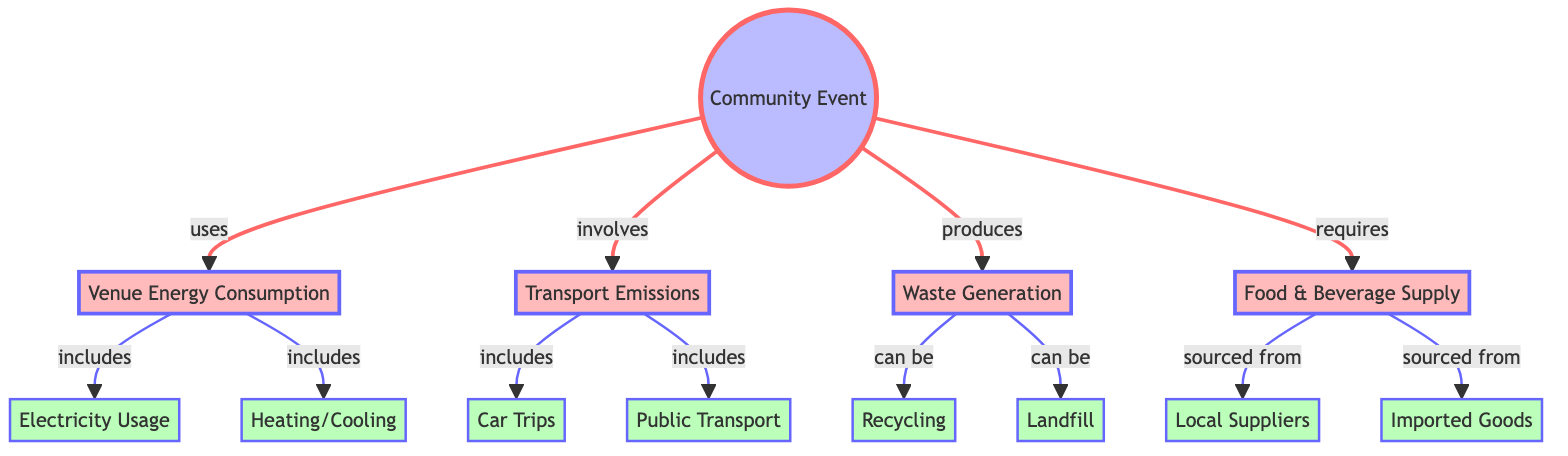What's the main subject of the diagram? The main subject of the diagram is located at the top node, labeled "Community Event," which indicates that the flowchart analyzes the carbon footprint associated with hosting such an event.
Answer: Community Event How many main sections are identified in the diagram? The main sections are divided into four categories: Venue Energy Consumption, Transport Emissions, Waste Generation, and Food & Beverage Supply. These can be identified as the immediate nodes directly connected to the main subject node.
Answer: 4 Which section includes electricity usage? The section that includes electricity usage is labeled as "Venue Energy Consumption," which directly connects to the node "Electricity Usage."
Answer: Venue Energy Consumption How many nodes are there in total in the diagram? The total node count includes the main node and all subsequent nodes from each section. There are 13 nodes total when counting them independently.
Answer: 13 What relation does "Food & Beverage Supply" have with "Local Suppliers"? The relationship is indicative of sourcing, where "Food & Beverage Supply" can be sourced from "Local Suppliers," showing a direct connection.
Answer: sourced from Which type of transport is included under Transport Emissions? The two types of transport emitted under this category are "Car Trips" and "Public Transport," both of which are detailed as sub-nodes under the "Transport Emissions" section.
Answer: Car Trips and Public Transport What is the effect of waste generation in the diagram? The waste generation can either result in "Recycling" or lead to "Landfill," indicating its impact on environmental management. These outcomes can be seen as consequences stemming from the waste generation node.
Answer: Recycling and Landfill How is energy consumption broken down in the diagram? Energy consumption is broken down into two distinct categories: "Electricity Usage" and "Heating/Cooling," as both are directly connected to the "Venue Energy Consumption" node.
Answer: Electricity Usage and Heating/Cooling Which two nodes are directly connected under Waste Generation? The two nodes directly connected under Waste Generation are "Recycling" and "Landfill," both representing the outcomes of waste management.
Answer: Recycling and Landfill 